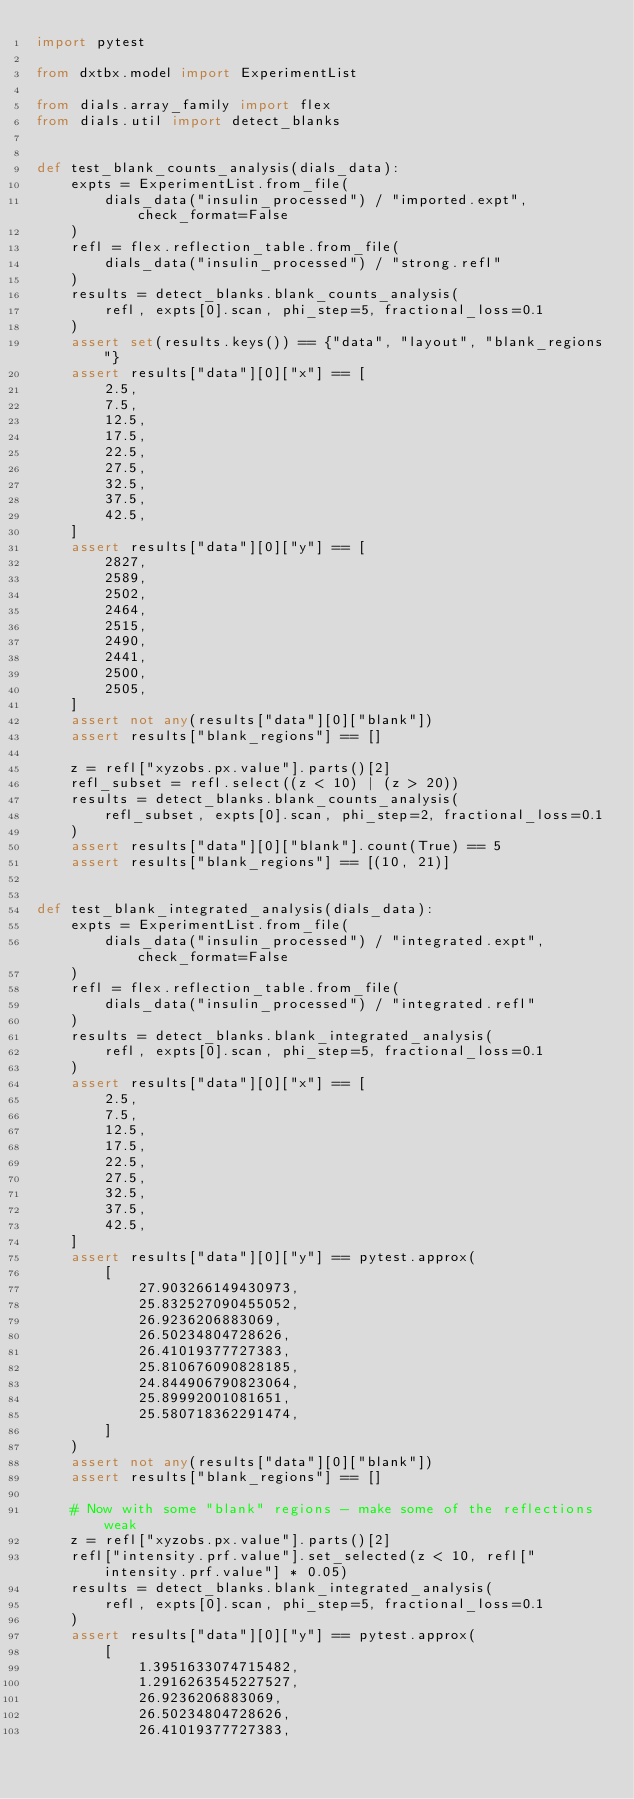Convert code to text. <code><loc_0><loc_0><loc_500><loc_500><_Python_>import pytest

from dxtbx.model import ExperimentList

from dials.array_family import flex
from dials.util import detect_blanks


def test_blank_counts_analysis(dials_data):
    expts = ExperimentList.from_file(
        dials_data("insulin_processed") / "imported.expt", check_format=False
    )
    refl = flex.reflection_table.from_file(
        dials_data("insulin_processed") / "strong.refl"
    )
    results = detect_blanks.blank_counts_analysis(
        refl, expts[0].scan, phi_step=5, fractional_loss=0.1
    )
    assert set(results.keys()) == {"data", "layout", "blank_regions"}
    assert results["data"][0]["x"] == [
        2.5,
        7.5,
        12.5,
        17.5,
        22.5,
        27.5,
        32.5,
        37.5,
        42.5,
    ]
    assert results["data"][0]["y"] == [
        2827,
        2589,
        2502,
        2464,
        2515,
        2490,
        2441,
        2500,
        2505,
    ]
    assert not any(results["data"][0]["blank"])
    assert results["blank_regions"] == []

    z = refl["xyzobs.px.value"].parts()[2]
    refl_subset = refl.select((z < 10) | (z > 20))
    results = detect_blanks.blank_counts_analysis(
        refl_subset, expts[0].scan, phi_step=2, fractional_loss=0.1
    )
    assert results["data"][0]["blank"].count(True) == 5
    assert results["blank_regions"] == [(10, 21)]


def test_blank_integrated_analysis(dials_data):
    expts = ExperimentList.from_file(
        dials_data("insulin_processed") / "integrated.expt", check_format=False
    )
    refl = flex.reflection_table.from_file(
        dials_data("insulin_processed") / "integrated.refl"
    )
    results = detect_blanks.blank_integrated_analysis(
        refl, expts[0].scan, phi_step=5, fractional_loss=0.1
    )
    assert results["data"][0]["x"] == [
        2.5,
        7.5,
        12.5,
        17.5,
        22.5,
        27.5,
        32.5,
        37.5,
        42.5,
    ]
    assert results["data"][0]["y"] == pytest.approx(
        [
            27.903266149430973,
            25.832527090455052,
            26.9236206883069,
            26.50234804728626,
            26.41019377727383,
            25.810676090828185,
            24.844906790823064,
            25.89992001081651,
            25.580718362291474,
        ]
    )
    assert not any(results["data"][0]["blank"])
    assert results["blank_regions"] == []

    # Now with some "blank" regions - make some of the reflections weak
    z = refl["xyzobs.px.value"].parts()[2]
    refl["intensity.prf.value"].set_selected(z < 10, refl["intensity.prf.value"] * 0.05)
    results = detect_blanks.blank_integrated_analysis(
        refl, expts[0].scan, phi_step=5, fractional_loss=0.1
    )
    assert results["data"][0]["y"] == pytest.approx(
        [
            1.3951633074715482,
            1.2916263545227527,
            26.9236206883069,
            26.50234804728626,
            26.41019377727383,</code> 